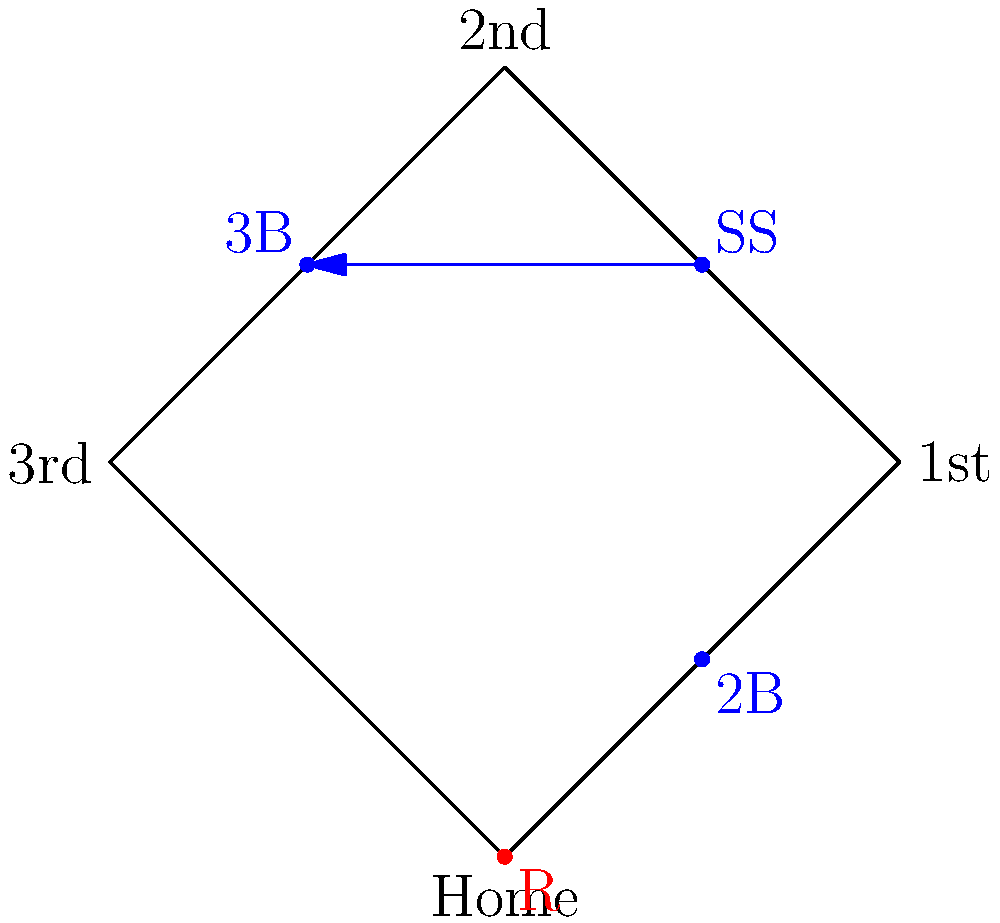In the diagram, a runner is at home plate, and the shortstop has the ball. The shortstop attempts to throw out the third baseman, creating a potential rundown situation. What is the optimal baserunning strategy for the runner to maximize their chances of safely reaching a base? To determine the optimal baserunning strategy, let's break down the situation step-by-step:

1. The runner is at home plate, which gives them the advantage of observing the entire play unfold.

2. The shortstop is throwing to the third baseman, indicating a potential miscommunication or strategic play by the defense.

3. This situation creates a rundown opportunity between third base and second base.

4. The optimal strategy for the runner is to:
   a) Start running towards first base as soon as the shortstop commits to throwing to third.
   b) Watch the throw carefully while running.
   c) If the throw is successful and the third baseman catches it, continue to first base at full speed.
   d) If the throw is errant or the third baseman mishandles it, make a quick decision:
      - If the ball goes past the third baseman, consider trying for second base.
      - If the third baseman bobbles the ball but retains possession, stay at first base.

5. The reasoning behind this strategy:
   - Running to first base is the safest initial move, as it's the shortest distance and doesn't risk an immediate tag out.
   - By watching the throw, the runner can capitalize on any defensive mistakes.
   - If executed correctly, this strategy puts pressure on the defense and may force additional errors.

6. The runner should avoid:
   - Hesitating at home plate, which would give the defense time to recover from their mistake.
   - Immediately trying for second or third base, which would be too risky given the positions of the fielders.

By following this strategy, the runner maximizes their chances of safely reaching a base while minimizing the risk of being tagged out.
Answer: Run to first, watch throw, advance if error occurs. 